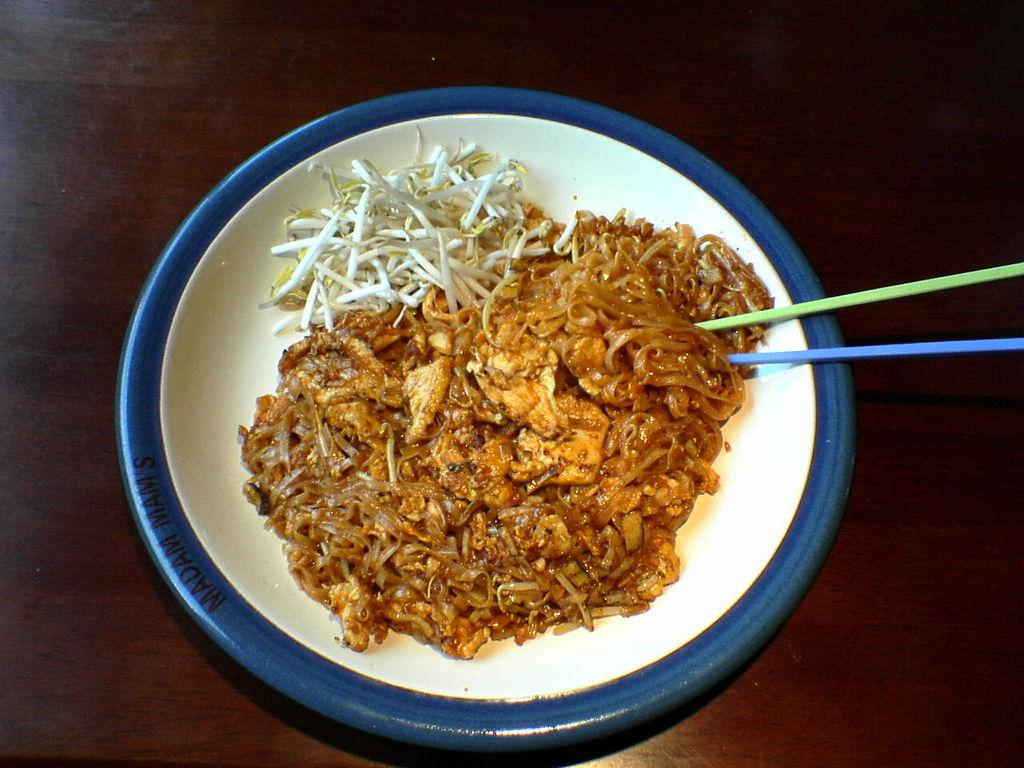What color is the plate in the image? The plate in the image is blue. What is on the plate? Food is placed on the plate. What utensils are present below the plate? There are two chopsticks below the plate. What type of furniture is in the image? There is a wooden table in the image. What word is being represented by the food on the plate? There is no word being represented by the food on the plate; it is simply food placed on a plate. 